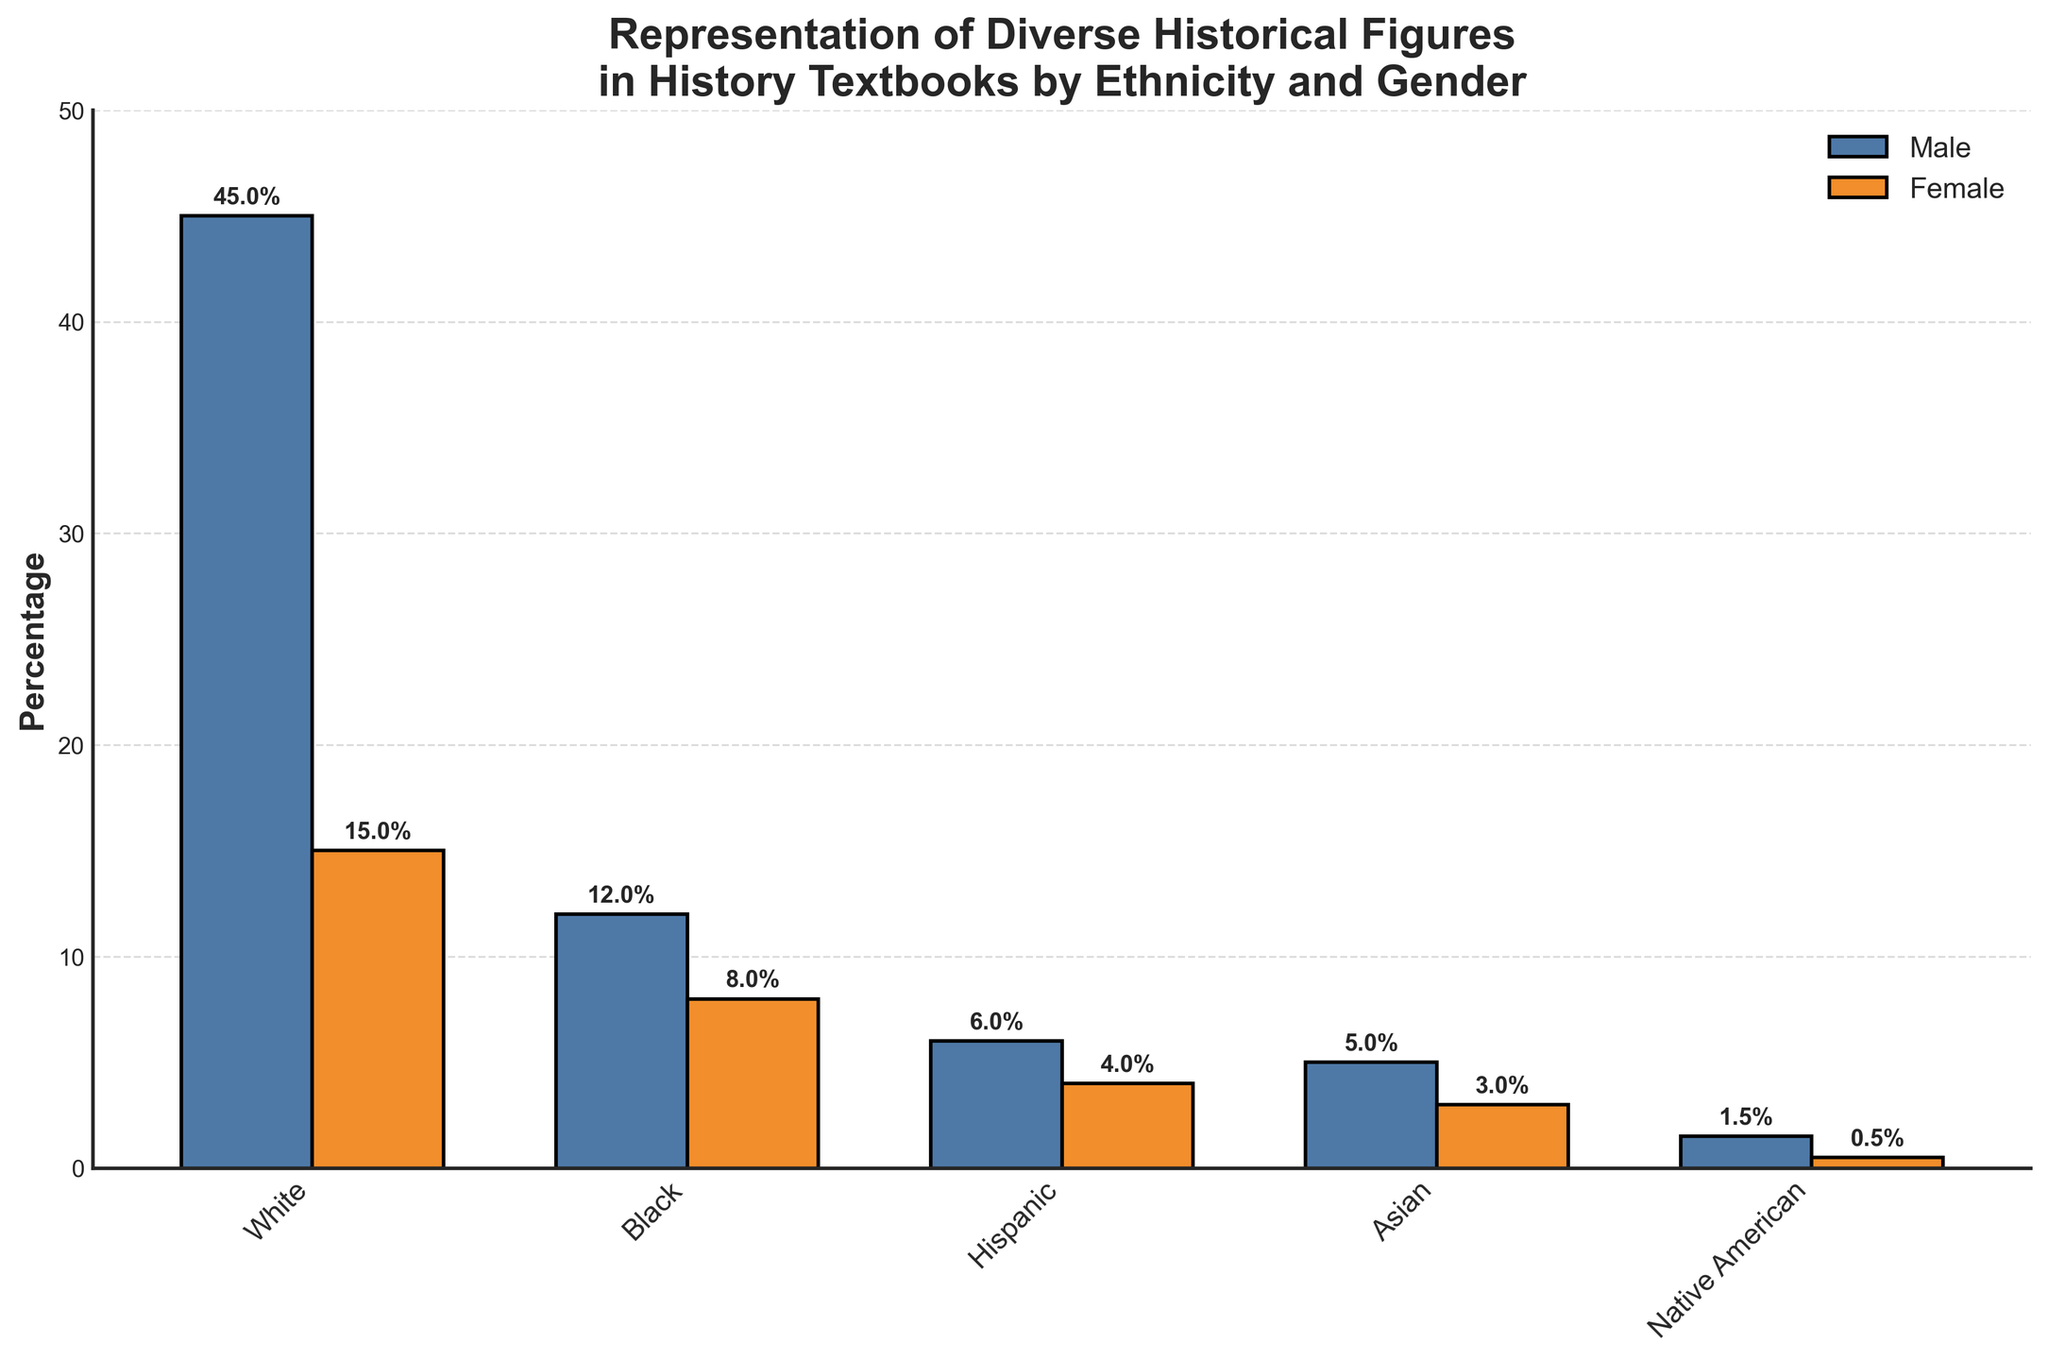Which ethnicity has the highest representation among males? To find this, look at the heights of the bars representing males for each ethnicity in the chart. The tallest bar is for "White" males.
Answer: White What is the combined percentage of representation for Black males and females? Add the percentage for Black males (12%) and Black females (8%). 12% + 8% = 20%
Answer: 20% Compare the representation percentage between Hispanic males and Native American males. Which group is higher? Look at the height of the bars for Hispanic and Native American males. Hispanic males have a 6% representation, while Native American males have a 1.5% representation. 6% is greater than 1.5%.
Answer: Hispanic males How much greater is the representation of White males compared to Asian males? Subtract the percentage of Asian males (5%) from the percentage of White males (45%). 45% - 5% = 40%
Answer: 40% Which gender has a higher representation among Asian historical figures? Compare the heights of the bars for Asian males and females. The bar for Asian males (5%) is higher than the bar for Asian females (3%).
Answer: Male What is the average representation percentage of females across all ethnicities? Add the percentages for all ethnic groups for females and divide by the number of groups: (15% + 8% + 4% + 3% + 0.5%) / 5. (15 + 8 + 4 + 3 + 0.5) = 30.5; then 30.5 / 5 = 6.1%
Answer: 6.1% Which ethnicity has the lowest female representation? Look at the heights of the bars representing females for each ethnicity. Native American females have the lowest bar at 0.5%.
Answer: Native American By how much does the representation of White females exceed that of Hispanic females? Subtract the percentage of Hispanic females (4%) from White females (15%). 15% - 4% = 11%
Answer: 11% What is the total representation percentage of all males in the figure? Add the percentages for all male ethnic groups: 45% + 12% + 6% + 5% + 1.5% = 69.5%
Answer: 69.5% How does the representation of Black females compare to Hispanic males' representation? Compare the percentages of Black females (8%) and Hispanic males (6%). 8% is greater than 6%.
Answer: Black females are higher 